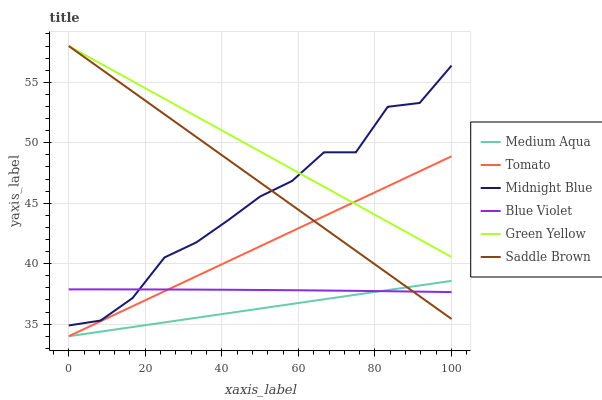Does Midnight Blue have the minimum area under the curve?
Answer yes or no. No. Does Midnight Blue have the maximum area under the curve?
Answer yes or no. No. Is Medium Aqua the smoothest?
Answer yes or no. No. Is Medium Aqua the roughest?
Answer yes or no. No. Does Midnight Blue have the lowest value?
Answer yes or no. No. Does Midnight Blue have the highest value?
Answer yes or no. No. Is Blue Violet less than Green Yellow?
Answer yes or no. Yes. Is Green Yellow greater than Blue Violet?
Answer yes or no. Yes. Does Blue Violet intersect Green Yellow?
Answer yes or no. No. 